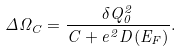Convert formula to latex. <formula><loc_0><loc_0><loc_500><loc_500>\Delta \Omega _ { C } = \frac { \delta Q _ { 0 } ^ { 2 } } { C + e ^ { 2 } D ( E _ { F } ) } .</formula> 